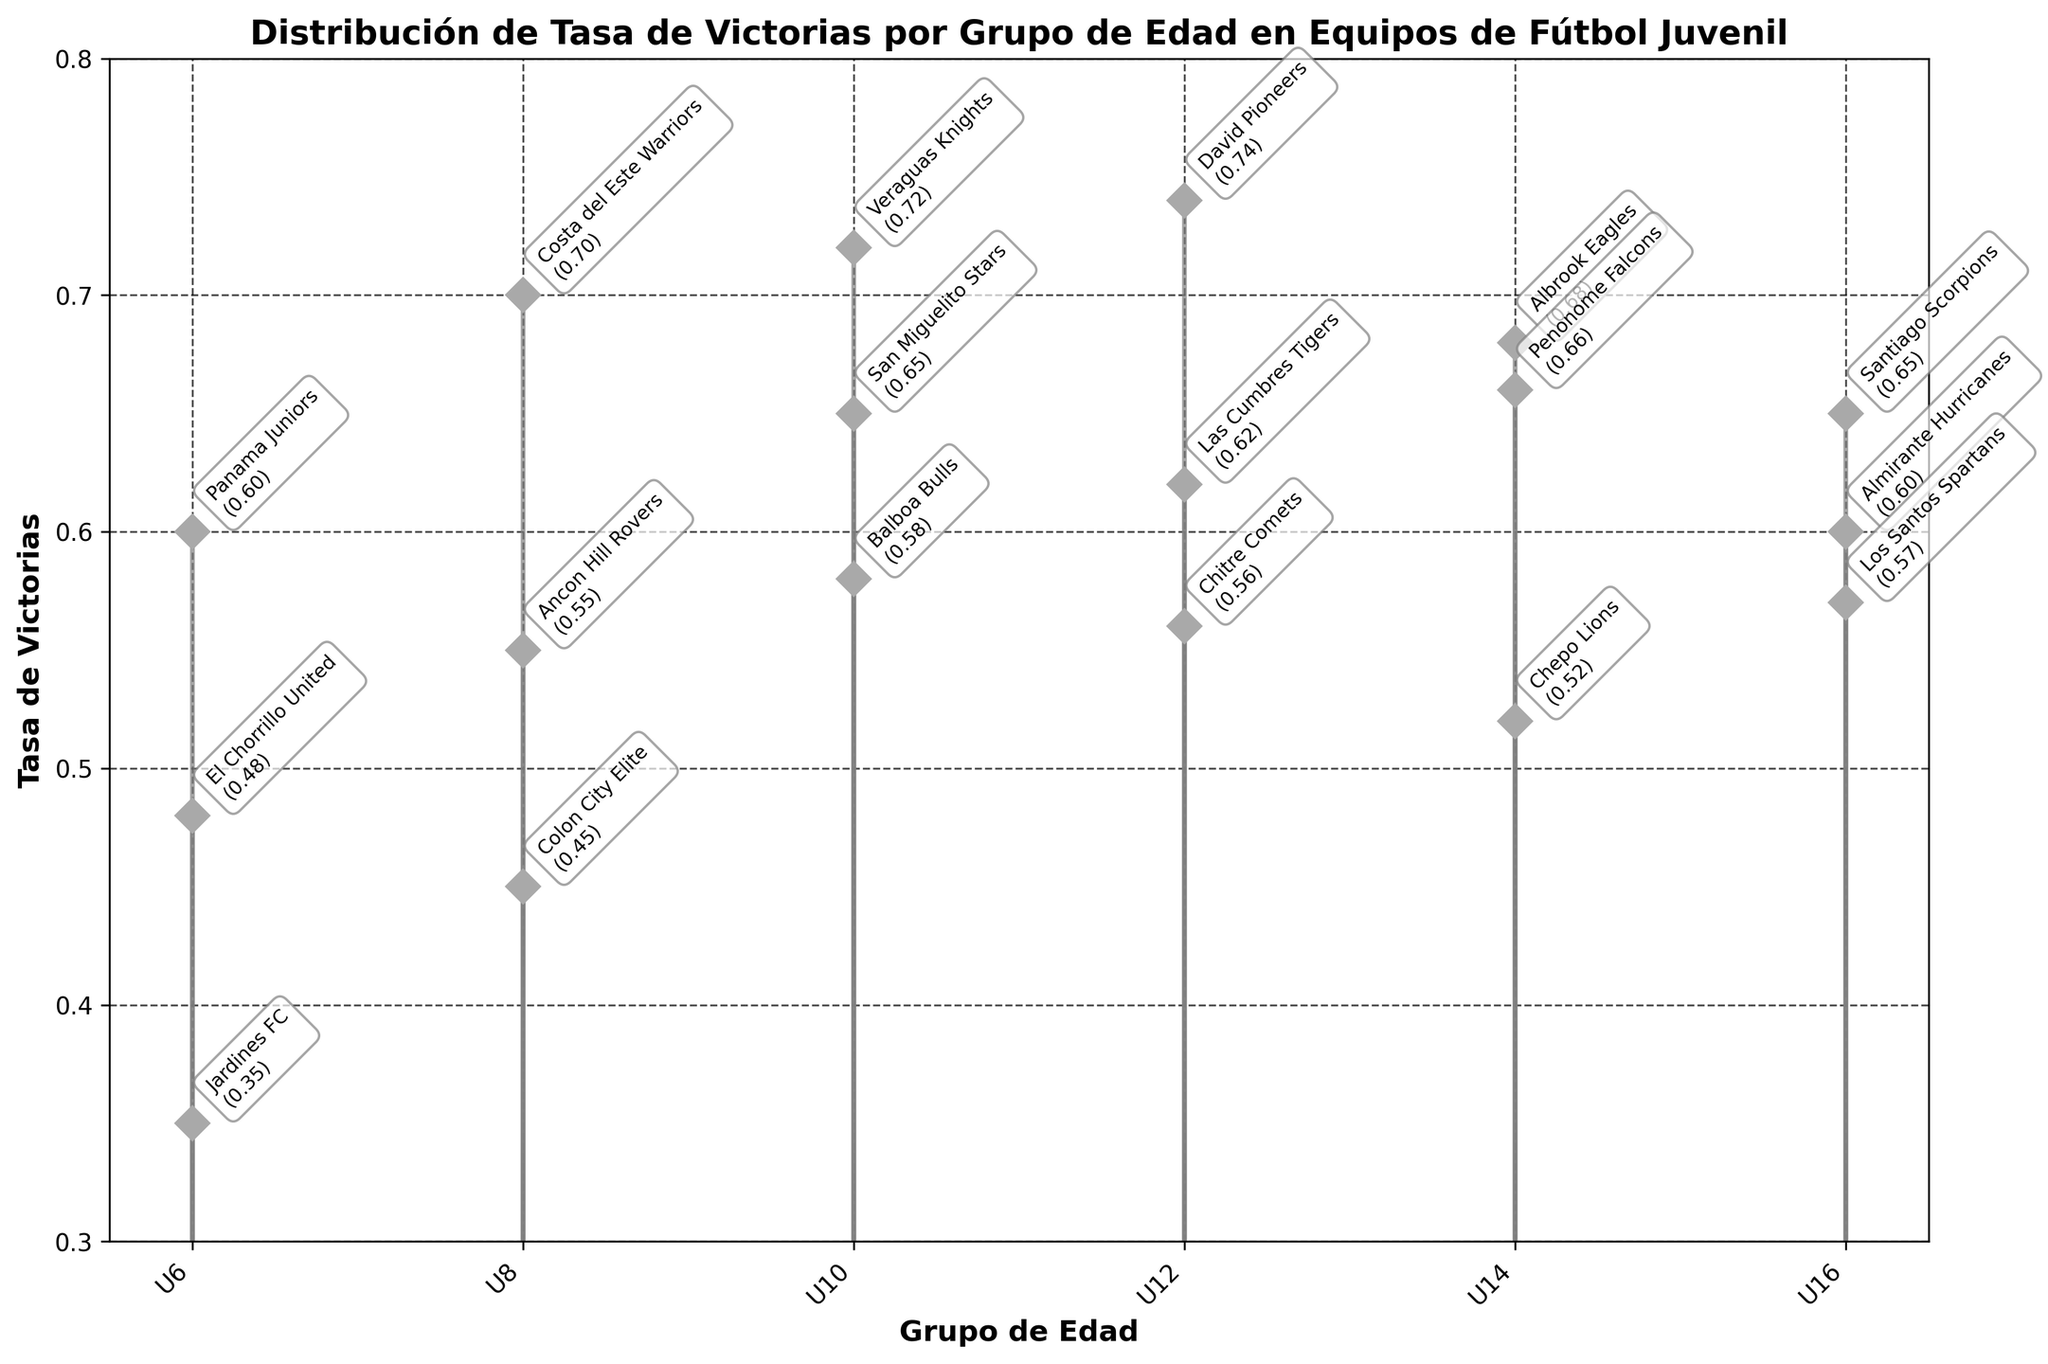What's the title of the plot? The title is displayed at the top of the plot. It provides the subject of the plot.
Answer: Distribución de Tasa de Victorias por Grupo de Edad en Equipos de Fútbol Juvenil Which age group has the highest win rate? Identify the highest win rate in the plot, then check the corresponding age group on the x-axis. The U12 group has a win rate of 0.74.
Answer: U12 What is the win rate of Panama Juniors? Look at the group "U6" and find Panama Juniors, which has a win rate annotated next to it.
Answer: 0.60 How many age groups are represented in the plot? Count the different age groups labeled on the x-axis.
Answer: 5 Which team has the lowest win rate in the U6 category? Look at the U6 age group on the x-axis and identify the team with the smallest point on the y-axis.
Answer: Jardines FC What's the average win rate for the U8 age group? The win rates for U8 are 0.55, 0.70, and 0.45. The average is calculated as (0.55 + 0.70 + 0.45) / 3 = 1.70 / 3 = 0.56667
Answer: 0.57 Which teams have a win rate of 0.60? Look for points at the 0.60 mark and check the annotated team names.
Answer: Panama Juniors, Almirante Hurricanes How does the win rate of Colon City Elite compare to that of Balboa Bulls? Compare the win rates of Colon City Elite (0.45) and Balboa Bulls (0.58) visually on the plot.
Answer: Balboa Bulls have a higher win rate Which age group has the most teams with a win rate annotated? Check the number of annotations under each age group in the plot. U10 group has three annotations.
Answer: U10 